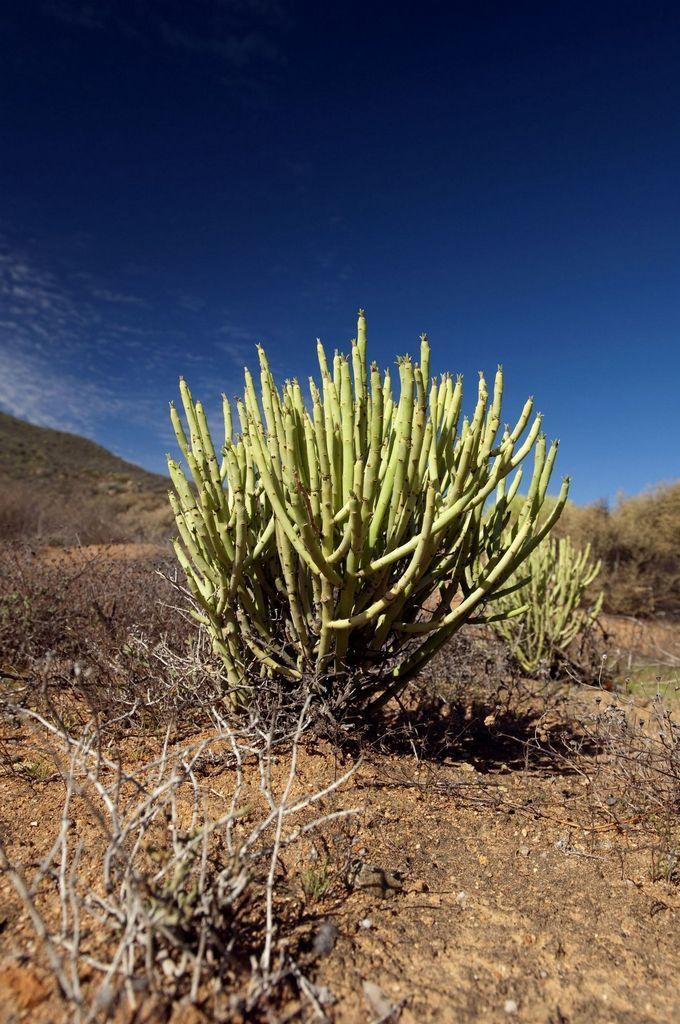What type of living organisms can be seen in the image? Plants can be seen in the image. What is the color of the ground in the image? The ground in the image is brown in color. What is visible in the sky in the image? The sky is visible in the image and is blue in color. Are there any cherries growing on the plants in the image? There is no mention of cherries in the provided facts, so we cannot determine if they are present in the image. Can you see a river flowing through the image? There is no mention of a river in the provided facts, so we cannot determine if it is present in the image. 